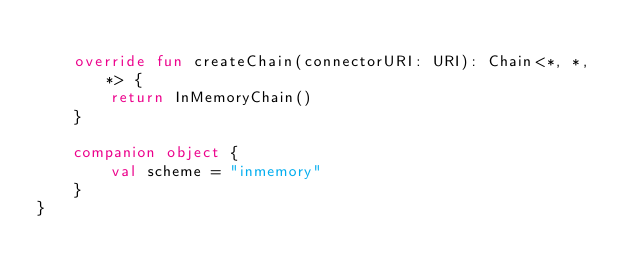<code> <loc_0><loc_0><loc_500><loc_500><_Kotlin_>
    override fun createChain(connectorURI: URI): Chain<*, *, *> {
        return InMemoryChain()
    }

    companion object {
        val scheme = "inmemory"
    }
}</code> 